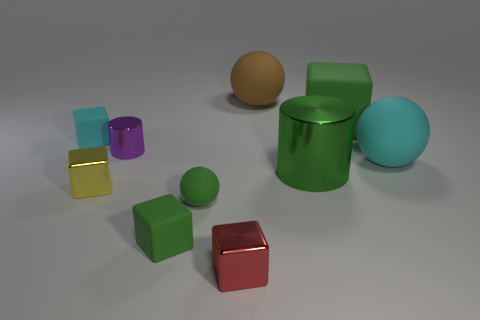How do the colors of the objects contribute to the overall aesthetic of the image? The colors in this image play a major role in its visual impact. The use of primary and secondary colors creates a vibrant and contrasting palette that draws the eye and creates depth through color differentiation. This choice of colors imbues the image with a playful and dynamic quality while allowing each object to stand distinct from the others, enhancing their individual shapes and textures. 